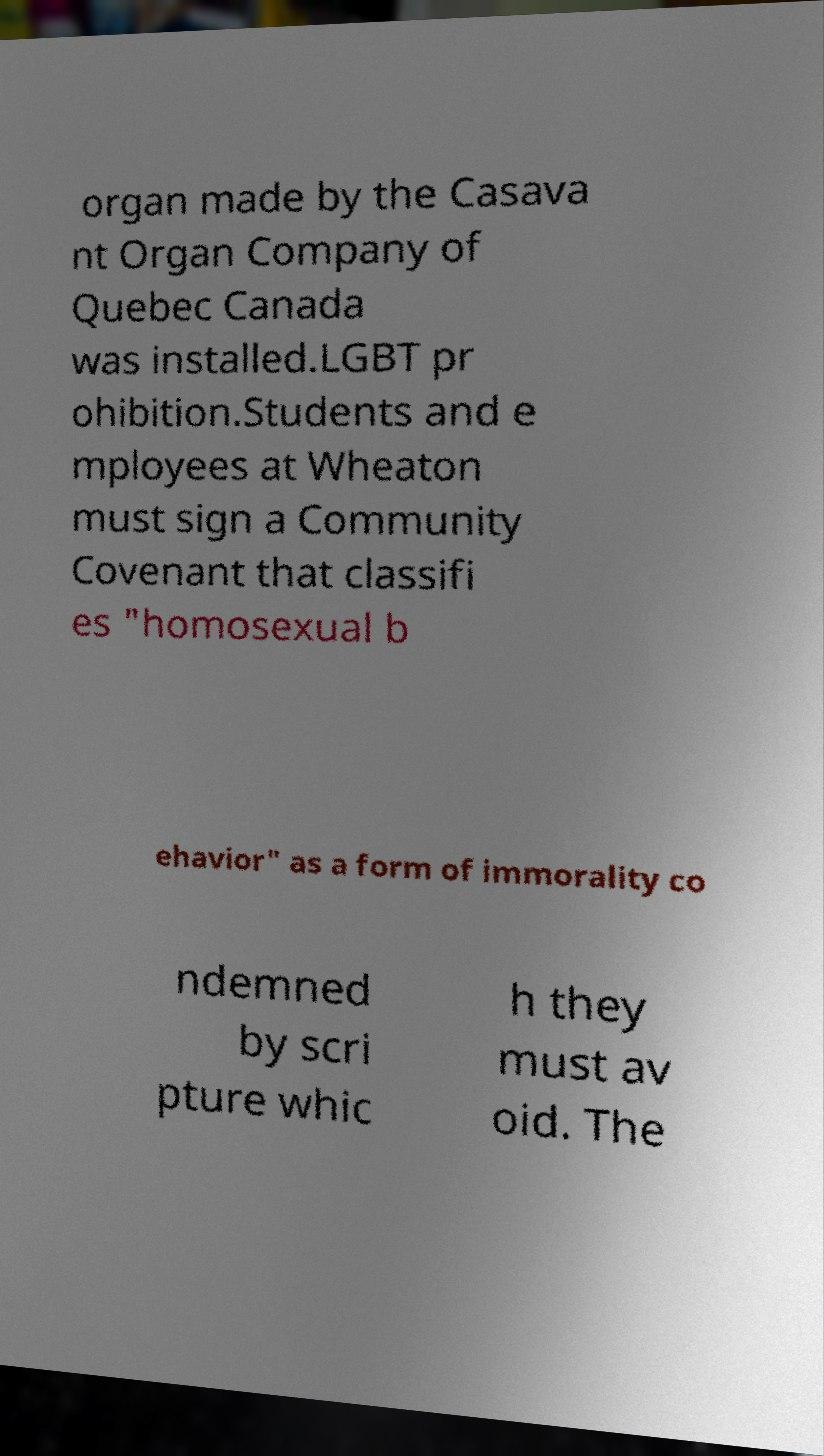There's text embedded in this image that I need extracted. Can you transcribe it verbatim? organ made by the Casava nt Organ Company of Quebec Canada was installed.LGBT pr ohibition.Students and e mployees at Wheaton must sign a Community Covenant that classifi es "homosexual b ehavior" as a form of immorality co ndemned by scri pture whic h they must av oid. The 